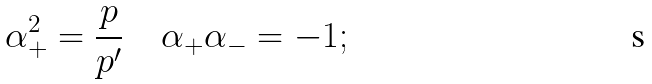<formula> <loc_0><loc_0><loc_500><loc_500>\alpha _ { + } ^ { 2 } = \frac { p } { p ^ { \prime } } \quad \alpha _ { + } \alpha _ { - } = - 1 ;</formula> 